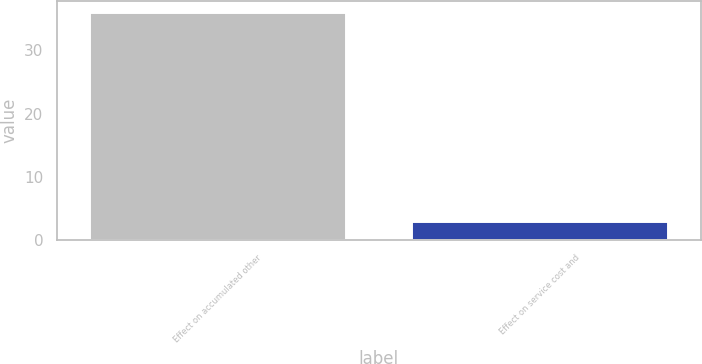Convert chart to OTSL. <chart><loc_0><loc_0><loc_500><loc_500><bar_chart><fcel>Effect on accumulated other<fcel>Effect on service cost and<nl><fcel>36<fcel>3<nl></chart> 